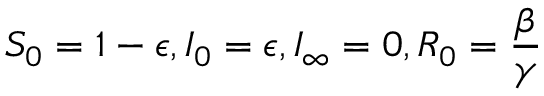Convert formula to latex. <formula><loc_0><loc_0><loc_500><loc_500>S _ { 0 } = 1 - \epsilon , I _ { 0 } = \epsilon , I _ { \infty } = 0 , R _ { 0 } = \frac { \beta } { \gamma }</formula> 